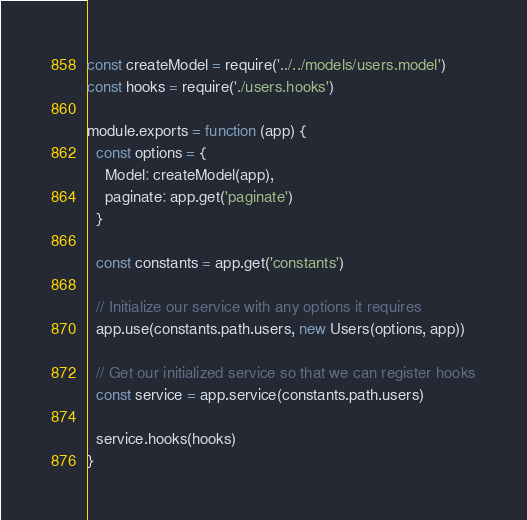<code> <loc_0><loc_0><loc_500><loc_500><_JavaScript_>const createModel = require('../../models/users.model')
const hooks = require('./users.hooks')

module.exports = function (app) {
  const options = {
    Model: createModel(app),
    paginate: app.get('paginate')
  }

  const constants = app.get('constants')

  // Initialize our service with any options it requires
  app.use(constants.path.users, new Users(options, app))

  // Get our initialized service so that we can register hooks
  const service = app.service(constants.path.users)

  service.hooks(hooks)
}
</code> 